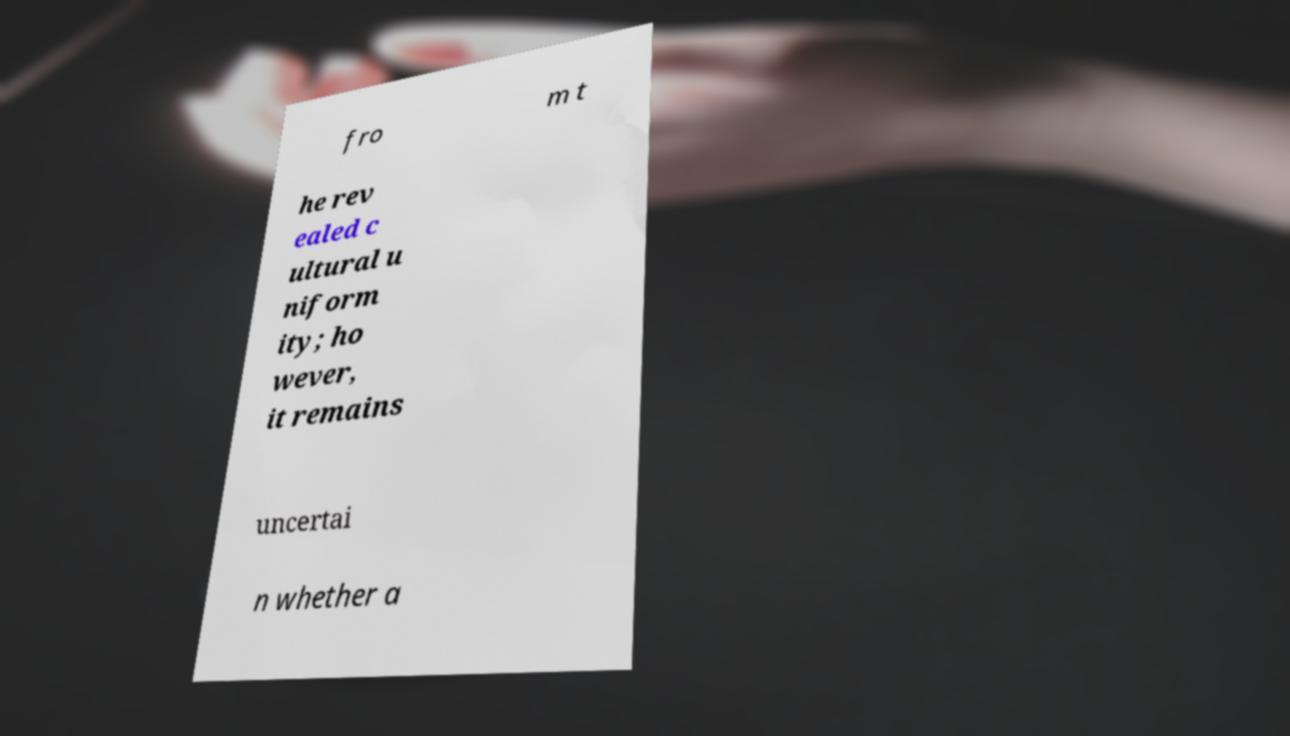Can you accurately transcribe the text from the provided image for me? fro m t he rev ealed c ultural u niform ity; ho wever, it remains uncertai n whether a 